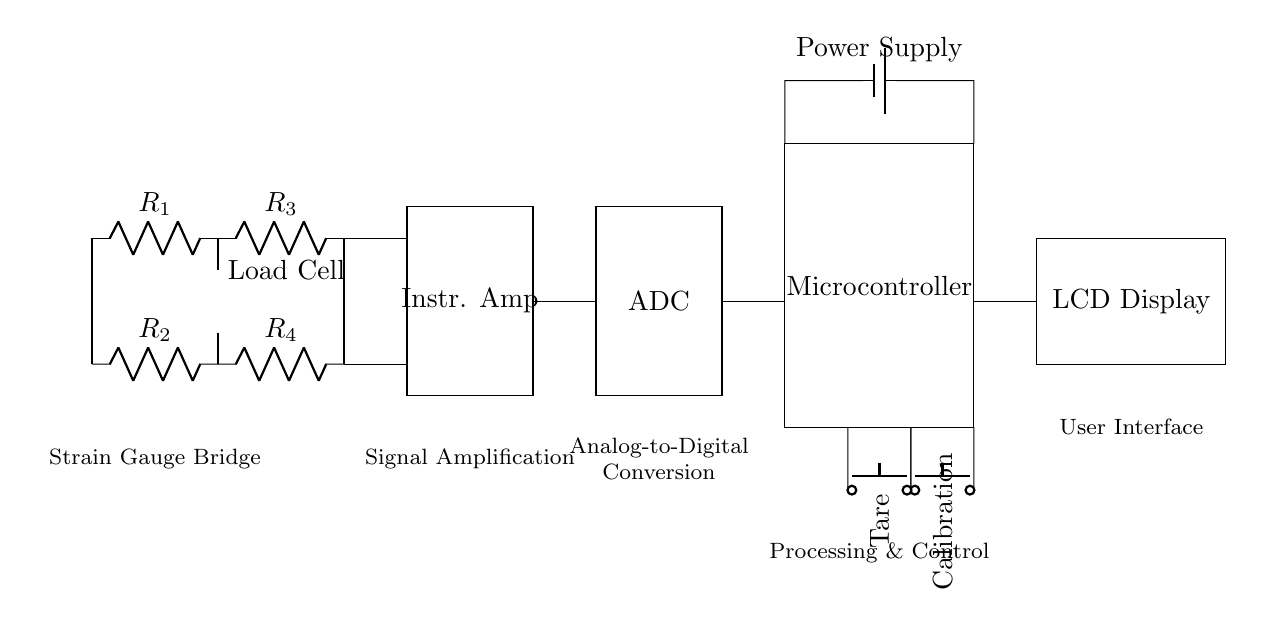What type of circuit is shown? The circuit represents a high-precision electronic scale circuit designed for weighing precious metals and coins, as indicated by its components such as the load cell, instrumentation amplifier, and digital display.
Answer: High-precision electronic scale circuit How many resistors are in the load cell? There are four resistors (R1, R2, R3, R4) depicted in the load cell section of the circuit diagram, highlighting the strain gauge bridge configuration.
Answer: Four What is the function of the instrumentation amplifier? The instrumentation amplifier amplifies the signal from the load cell, facilitating accurate readings of the small changes in resistance due to weight applied on the scale.
Answer: Signal amplification Which component converts the analog signal to a digital signal? The component that performs this function is the ADC (Analog-to-Digital Converter), which is responsible for converting amplified analog signals into digital form for microcontroller processing.
Answer: ADC What is the purpose of the calibration button? The calibration button allows the user to reset or adjust the scale's measurements, ensuring accuracy when weighing with different reference standards or weights.
Answer: Calibration How is the power supply connected in the circuit? The power supply is connected between the microcontroller and the load cell, providing necessary voltage and current to the circuit components, facilitating their operation.
Answer: Battery What does the LCD display indicate? The LCD display presents the weight measurements of the precious metals or coins being weighed, providing a direct, visual output of the processed digital signal.
Answer: Weight measurement 